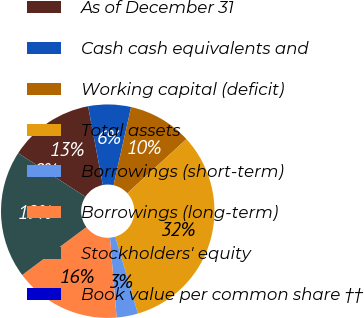Convert chart. <chart><loc_0><loc_0><loc_500><loc_500><pie_chart><fcel>As of December 31<fcel>Cash cash equivalents and<fcel>Working capital (deficit)<fcel>Total assets<fcel>Borrowings (short-term)<fcel>Borrowings (long-term)<fcel>Stockholders' equity<fcel>Book value per common share ††<nl><fcel>12.9%<fcel>6.46%<fcel>9.68%<fcel>32.24%<fcel>3.23%<fcel>16.13%<fcel>19.35%<fcel>0.01%<nl></chart> 